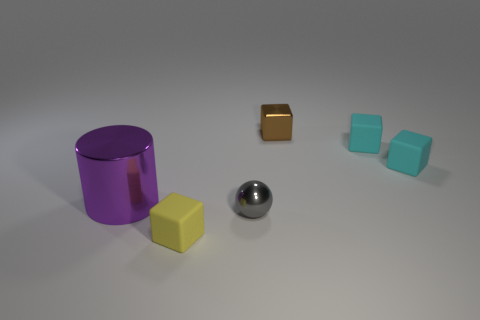Are there any other things that are the same size as the cylinder?
Keep it short and to the point. No. Are there fewer big purple objects that are behind the big metallic cylinder than small gray spheres?
Your response must be concise. Yes. Does the yellow matte thing have the same shape as the brown metallic object?
Make the answer very short. Yes. Is there anything else that is the same shape as the brown thing?
Keep it short and to the point. Yes. Are any gray metal objects visible?
Your answer should be compact. Yes. There is a gray metallic object; is it the same shape as the metallic object to the right of the gray shiny ball?
Offer a terse response. No. The thing to the left of the small yellow matte object that is in front of the large purple cylinder is made of what material?
Your answer should be compact. Metal. What is the color of the cylinder?
Your answer should be very brief. Purple. What size is the yellow matte thing that is the same shape as the tiny brown thing?
Offer a terse response. Small. How many things are tiny matte things right of the tiny yellow object or gray things?
Your answer should be compact. 3. 